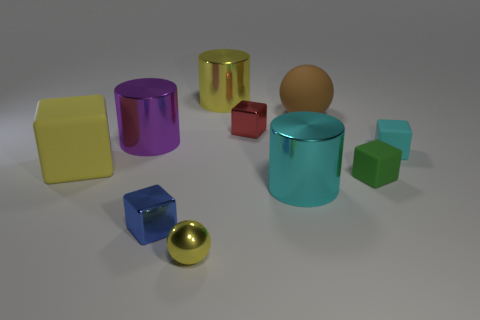There is a big shiny object that is the same color as the big block; what shape is it?
Give a very brief answer. Cylinder. What number of blue cubes have the same size as the rubber sphere?
Ensure brevity in your answer.  0. Are there fewer green blocks in front of the small cyan object than blue metal things?
Your response must be concise. No. There is a brown matte sphere; how many brown rubber balls are behind it?
Your answer should be very brief. 0. There is a yellow metal object that is behind the tiny matte block in front of the big matte thing in front of the large purple thing; what is its size?
Ensure brevity in your answer.  Large. There is a large cyan shiny thing; is it the same shape as the yellow thing that is behind the yellow block?
Give a very brief answer. Yes. What size is the blue thing that is made of the same material as the large purple thing?
Provide a short and direct response. Small. Is there anything else that is the same color as the large block?
Offer a very short reply. Yes. What material is the big yellow thing that is behind the large yellow thing that is on the left side of the yellow metal object that is on the left side of the large yellow shiny cylinder?
Ensure brevity in your answer.  Metal. How many rubber objects are either tiny red things or big cyan cylinders?
Your answer should be very brief. 0. 